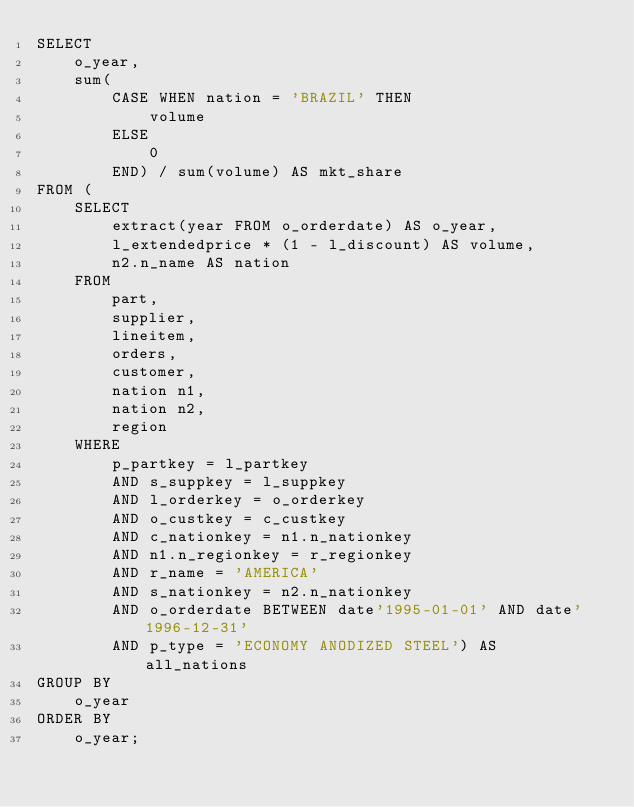Convert code to text. <code><loc_0><loc_0><loc_500><loc_500><_SQL_>SELECT
    o_year,
    sum(
        CASE WHEN nation = 'BRAZIL' THEN
            volume
        ELSE
            0
        END) / sum(volume) AS mkt_share
FROM (
    SELECT
        extract(year FROM o_orderdate) AS o_year,
        l_extendedprice * (1 - l_discount) AS volume,
        n2.n_name AS nation
    FROM
        part,
        supplier,
        lineitem,
        orders,
        customer,
        nation n1,
        nation n2,
        region
    WHERE
        p_partkey = l_partkey
        AND s_suppkey = l_suppkey
        AND l_orderkey = o_orderkey
        AND o_custkey = c_custkey
        AND c_nationkey = n1.n_nationkey
        AND n1.n_regionkey = r_regionkey
        AND r_name = 'AMERICA'
        AND s_nationkey = n2.n_nationkey
        AND o_orderdate BETWEEN date'1995-01-01' AND date'1996-12-31'
        AND p_type = 'ECONOMY ANODIZED STEEL') AS all_nations
GROUP BY
    o_year
ORDER BY
    o_year;
</code> 